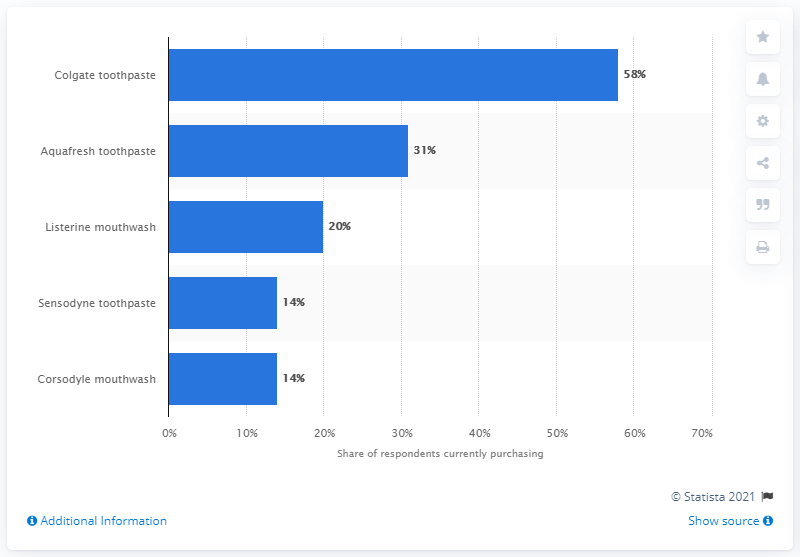Draw attention to some important aspects in this diagram. The most popular toothpaste brand in the UK is Colgate. 